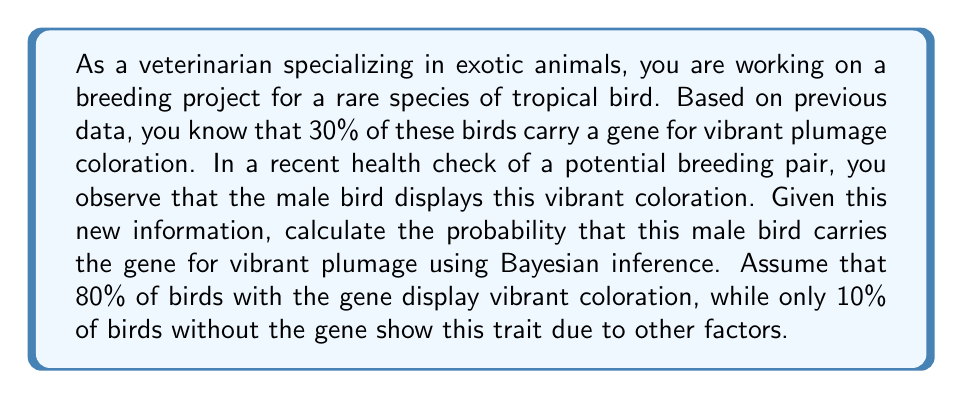Can you solve this math problem? To solve this problem, we'll use Bayes' theorem, which is fundamental in Bayesian inference. Let's define our events:

A: The bird carries the gene for vibrant plumage
B: The bird displays vibrant coloration

We're given the following probabilities:

$P(A) = 0.30$ (prior probability of carrying the gene)
$P(B|A) = 0.80$ (probability of vibrant coloration given the gene)
$P(B|\neg A) = 0.10$ (probability of vibrant coloration without the gene)

We want to find $P(A|B)$, the probability that the bird carries the gene given that it displays vibrant coloration.

Bayes' theorem states:

$$P(A|B) = \frac{P(B|A) \cdot P(A)}{P(B)}$$

To calculate $P(B)$, we use the law of total probability:

$$P(B) = P(B|A) \cdot P(A) + P(B|\neg A) \cdot P(\neg A)$$

Let's calculate step by step:

1) $P(\neg A) = 1 - P(A) = 1 - 0.30 = 0.70$

2) $P(B) = (0.80 \cdot 0.30) + (0.10 \cdot 0.70) = 0.24 + 0.07 = 0.31$

3) Now we can apply Bayes' theorem:

   $$P(A|B) = \frac{0.80 \cdot 0.30}{0.31} = \frac{0.24}{0.31} \approx 0.7742$$

Therefore, the probability that the male bird carries the gene for vibrant plumage, given that it displays vibrant coloration, is approximately 0.7742 or 77.42%.
Answer: 0.7742 (or 77.42%) 